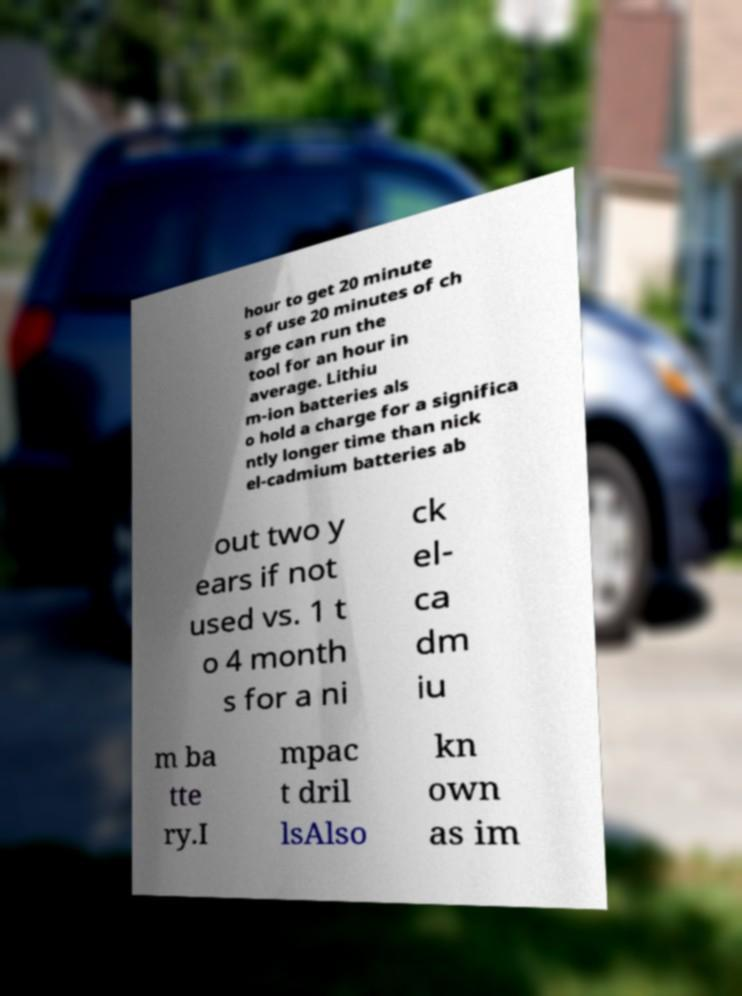Can you accurately transcribe the text from the provided image for me? hour to get 20 minute s of use 20 minutes of ch arge can run the tool for an hour in average. Lithiu m-ion batteries als o hold a charge for a significa ntly longer time than nick el-cadmium batteries ab out two y ears if not used vs. 1 t o 4 month s for a ni ck el- ca dm iu m ba tte ry.I mpac t dril lsAlso kn own as im 